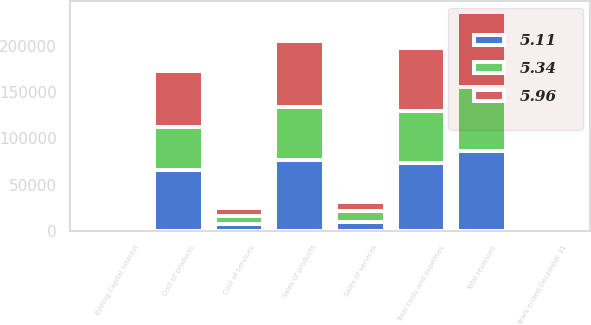Convert chart to OTSL. <chart><loc_0><loc_0><loc_500><loc_500><stacked_bar_chart><ecel><fcel>Years ended December 31<fcel>Sales of products<fcel>Sales of services<fcel>Total revenues<fcel>Cost of products<fcel>Cost of services<fcel>Boeing Capital interest<fcel>Total costs and expenses<nl><fcel>5.11<fcel>2013<fcel>76792<fcel>9831<fcel>86623<fcel>65640<fcel>7553<fcel>75<fcel>73268<nl><fcel>5.96<fcel>2012<fcel>71234<fcel>10464<fcel>81698<fcel>60309<fcel>8247<fcel>109<fcel>68665<nl><fcel>5.34<fcel>2011<fcel>57401<fcel>11334<fcel>68735<fcel>46642<fcel>9097<fcel>149<fcel>55888<nl></chart> 